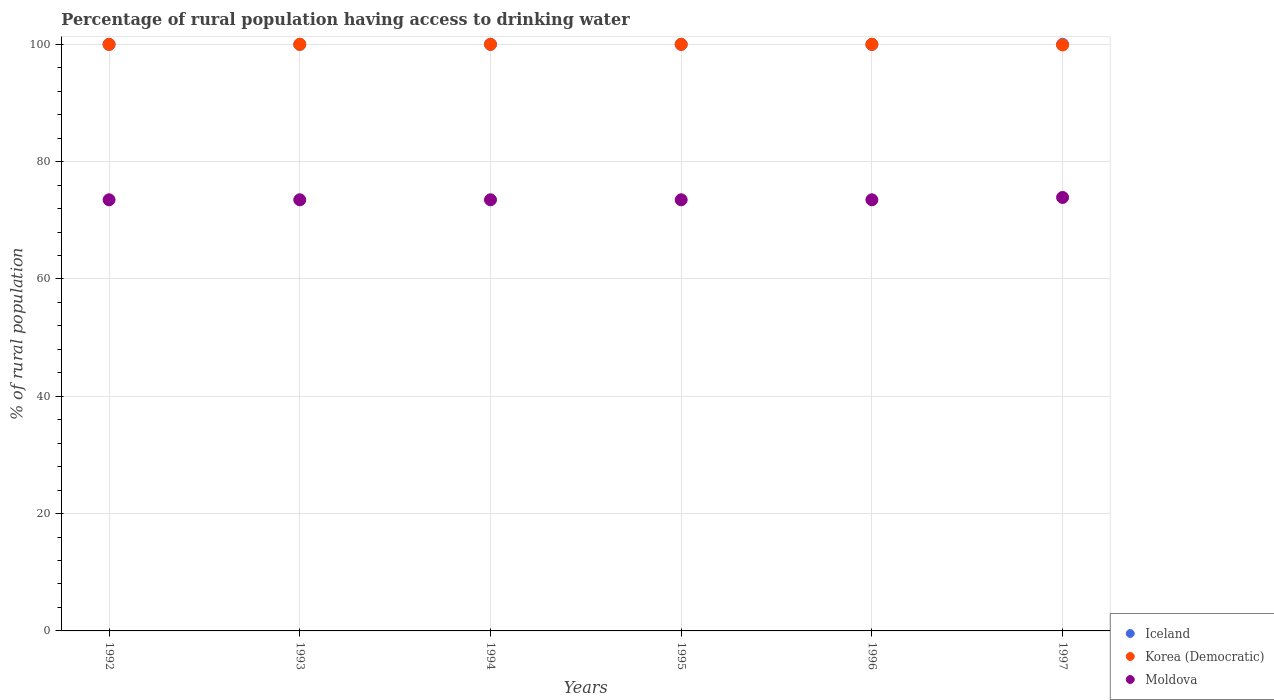Is the number of dotlines equal to the number of legend labels?
Make the answer very short. Yes. What is the percentage of rural population having access to drinking water in Moldova in 1995?
Offer a very short reply. 73.5. Across all years, what is the minimum percentage of rural population having access to drinking water in Korea (Democratic)?
Give a very brief answer. 99.9. What is the total percentage of rural population having access to drinking water in Iceland in the graph?
Your response must be concise. 600. What is the difference between the percentage of rural population having access to drinking water in Korea (Democratic) in 1992 and that in 1994?
Keep it short and to the point. 0. What is the difference between the percentage of rural population having access to drinking water in Moldova in 1992 and the percentage of rural population having access to drinking water in Iceland in 1997?
Provide a succinct answer. -26.5. What is the average percentage of rural population having access to drinking water in Moldova per year?
Give a very brief answer. 73.57. In the year 1992, what is the difference between the percentage of rural population having access to drinking water in Moldova and percentage of rural population having access to drinking water in Korea (Democratic)?
Your answer should be very brief. -26.5. What is the ratio of the percentage of rural population having access to drinking water in Moldova in 1992 to that in 1995?
Give a very brief answer. 1. Is the percentage of rural population having access to drinking water in Korea (Democratic) in 1995 less than that in 1997?
Give a very brief answer. No. Is the difference between the percentage of rural population having access to drinking water in Moldova in 1993 and 1995 greater than the difference between the percentage of rural population having access to drinking water in Korea (Democratic) in 1993 and 1995?
Provide a succinct answer. No. What is the difference between the highest and the second highest percentage of rural population having access to drinking water in Iceland?
Offer a terse response. 0. What is the difference between the highest and the lowest percentage of rural population having access to drinking water in Korea (Democratic)?
Make the answer very short. 0.1. In how many years, is the percentage of rural population having access to drinking water in Iceland greater than the average percentage of rural population having access to drinking water in Iceland taken over all years?
Your answer should be compact. 0. Is the sum of the percentage of rural population having access to drinking water in Moldova in 1992 and 1997 greater than the maximum percentage of rural population having access to drinking water in Iceland across all years?
Your answer should be compact. Yes. How many dotlines are there?
Offer a very short reply. 3. How many years are there in the graph?
Offer a terse response. 6. What is the difference between two consecutive major ticks on the Y-axis?
Your response must be concise. 20. Does the graph contain grids?
Ensure brevity in your answer.  Yes. Where does the legend appear in the graph?
Your answer should be very brief. Bottom right. How many legend labels are there?
Provide a succinct answer. 3. How are the legend labels stacked?
Offer a terse response. Vertical. What is the title of the graph?
Your answer should be very brief. Percentage of rural population having access to drinking water. Does "Macedonia" appear as one of the legend labels in the graph?
Provide a succinct answer. No. What is the label or title of the X-axis?
Your answer should be compact. Years. What is the label or title of the Y-axis?
Your response must be concise. % of rural population. What is the % of rural population of Korea (Democratic) in 1992?
Ensure brevity in your answer.  100. What is the % of rural population in Moldova in 1992?
Ensure brevity in your answer.  73.5. What is the % of rural population of Moldova in 1993?
Provide a short and direct response. 73.5. What is the % of rural population of Iceland in 1994?
Offer a terse response. 100. What is the % of rural population in Korea (Democratic) in 1994?
Give a very brief answer. 100. What is the % of rural population in Moldova in 1994?
Make the answer very short. 73.5. What is the % of rural population in Iceland in 1995?
Your answer should be very brief. 100. What is the % of rural population of Moldova in 1995?
Offer a very short reply. 73.5. What is the % of rural population in Iceland in 1996?
Ensure brevity in your answer.  100. What is the % of rural population of Moldova in 1996?
Your answer should be very brief. 73.5. What is the % of rural population in Iceland in 1997?
Offer a terse response. 100. What is the % of rural population in Korea (Democratic) in 1997?
Ensure brevity in your answer.  99.9. What is the % of rural population of Moldova in 1997?
Give a very brief answer. 73.9. Across all years, what is the maximum % of rural population in Iceland?
Offer a terse response. 100. Across all years, what is the maximum % of rural population in Korea (Democratic)?
Your answer should be very brief. 100. Across all years, what is the maximum % of rural population in Moldova?
Give a very brief answer. 73.9. Across all years, what is the minimum % of rural population of Iceland?
Offer a terse response. 100. Across all years, what is the minimum % of rural population of Korea (Democratic)?
Offer a very short reply. 99.9. Across all years, what is the minimum % of rural population in Moldova?
Your response must be concise. 73.5. What is the total % of rural population of Iceland in the graph?
Provide a succinct answer. 600. What is the total % of rural population in Korea (Democratic) in the graph?
Your answer should be compact. 599.9. What is the total % of rural population of Moldova in the graph?
Provide a succinct answer. 441.4. What is the difference between the % of rural population of Iceland in 1992 and that in 1993?
Your answer should be compact. 0. What is the difference between the % of rural population of Korea (Democratic) in 1992 and that in 1993?
Your response must be concise. 0. What is the difference between the % of rural population of Moldova in 1992 and that in 1993?
Make the answer very short. 0. What is the difference between the % of rural population of Iceland in 1992 and that in 1994?
Your answer should be compact. 0. What is the difference between the % of rural population of Korea (Democratic) in 1992 and that in 1994?
Ensure brevity in your answer.  0. What is the difference between the % of rural population in Moldova in 1992 and that in 1994?
Keep it short and to the point. 0. What is the difference between the % of rural population in Korea (Democratic) in 1992 and that in 1995?
Make the answer very short. 0. What is the difference between the % of rural population of Moldova in 1992 and that in 1995?
Your response must be concise. 0. What is the difference between the % of rural population of Iceland in 1992 and that in 1996?
Your response must be concise. 0. What is the difference between the % of rural population of Moldova in 1992 and that in 1996?
Offer a very short reply. 0. What is the difference between the % of rural population of Iceland in 1992 and that in 1997?
Give a very brief answer. 0. What is the difference between the % of rural population in Korea (Democratic) in 1992 and that in 1997?
Provide a short and direct response. 0.1. What is the difference between the % of rural population in Moldova in 1992 and that in 1997?
Your answer should be very brief. -0.4. What is the difference between the % of rural population of Iceland in 1993 and that in 1994?
Make the answer very short. 0. What is the difference between the % of rural population of Korea (Democratic) in 1993 and that in 1994?
Your answer should be compact. 0. What is the difference between the % of rural population in Moldova in 1993 and that in 1995?
Provide a succinct answer. 0. What is the difference between the % of rural population in Iceland in 1993 and that in 1996?
Give a very brief answer. 0. What is the difference between the % of rural population of Korea (Democratic) in 1993 and that in 1996?
Make the answer very short. 0. What is the difference between the % of rural population of Moldova in 1993 and that in 1996?
Give a very brief answer. 0. What is the difference between the % of rural population in Korea (Democratic) in 1993 and that in 1997?
Your answer should be compact. 0.1. What is the difference between the % of rural population in Moldova in 1993 and that in 1997?
Make the answer very short. -0.4. What is the difference between the % of rural population of Moldova in 1995 and that in 1996?
Make the answer very short. 0. What is the difference between the % of rural population of Iceland in 1996 and that in 1997?
Your answer should be very brief. 0. What is the difference between the % of rural population of Korea (Democratic) in 1996 and that in 1997?
Offer a very short reply. 0.1. What is the difference between the % of rural population of Iceland in 1992 and the % of rural population of Korea (Democratic) in 1993?
Your answer should be very brief. 0. What is the difference between the % of rural population of Korea (Democratic) in 1992 and the % of rural population of Moldova in 1993?
Offer a terse response. 26.5. What is the difference between the % of rural population in Iceland in 1992 and the % of rural population in Korea (Democratic) in 1994?
Your response must be concise. 0. What is the difference between the % of rural population of Korea (Democratic) in 1992 and the % of rural population of Moldova in 1994?
Offer a very short reply. 26.5. What is the difference between the % of rural population in Iceland in 1992 and the % of rural population in Moldova in 1995?
Offer a very short reply. 26.5. What is the difference between the % of rural population in Korea (Democratic) in 1992 and the % of rural population in Moldova in 1995?
Make the answer very short. 26.5. What is the difference between the % of rural population in Iceland in 1992 and the % of rural population in Korea (Democratic) in 1996?
Your response must be concise. 0. What is the difference between the % of rural population in Iceland in 1992 and the % of rural population in Moldova in 1996?
Ensure brevity in your answer.  26.5. What is the difference between the % of rural population in Korea (Democratic) in 1992 and the % of rural population in Moldova in 1996?
Ensure brevity in your answer.  26.5. What is the difference between the % of rural population in Iceland in 1992 and the % of rural population in Moldova in 1997?
Keep it short and to the point. 26.1. What is the difference between the % of rural population of Korea (Democratic) in 1992 and the % of rural population of Moldova in 1997?
Offer a terse response. 26.1. What is the difference between the % of rural population in Iceland in 1993 and the % of rural population in Korea (Democratic) in 1994?
Your answer should be very brief. 0. What is the difference between the % of rural population in Korea (Democratic) in 1993 and the % of rural population in Moldova in 1994?
Give a very brief answer. 26.5. What is the difference between the % of rural population of Iceland in 1993 and the % of rural population of Moldova in 1995?
Provide a succinct answer. 26.5. What is the difference between the % of rural population of Korea (Democratic) in 1993 and the % of rural population of Moldova in 1995?
Your answer should be very brief. 26.5. What is the difference between the % of rural population in Iceland in 1993 and the % of rural population in Korea (Democratic) in 1996?
Your answer should be compact. 0. What is the difference between the % of rural population of Iceland in 1993 and the % of rural population of Moldova in 1996?
Make the answer very short. 26.5. What is the difference between the % of rural population of Iceland in 1993 and the % of rural population of Korea (Democratic) in 1997?
Make the answer very short. 0.1. What is the difference between the % of rural population of Iceland in 1993 and the % of rural population of Moldova in 1997?
Your answer should be compact. 26.1. What is the difference between the % of rural population in Korea (Democratic) in 1993 and the % of rural population in Moldova in 1997?
Your answer should be very brief. 26.1. What is the difference between the % of rural population of Iceland in 1994 and the % of rural population of Korea (Democratic) in 1995?
Your response must be concise. 0. What is the difference between the % of rural population in Iceland in 1994 and the % of rural population in Moldova in 1995?
Your answer should be compact. 26.5. What is the difference between the % of rural population in Korea (Democratic) in 1994 and the % of rural population in Moldova in 1995?
Your answer should be very brief. 26.5. What is the difference between the % of rural population of Iceland in 1994 and the % of rural population of Moldova in 1996?
Make the answer very short. 26.5. What is the difference between the % of rural population of Iceland in 1994 and the % of rural population of Moldova in 1997?
Offer a very short reply. 26.1. What is the difference between the % of rural population of Korea (Democratic) in 1994 and the % of rural population of Moldova in 1997?
Offer a terse response. 26.1. What is the difference between the % of rural population of Iceland in 1995 and the % of rural population of Moldova in 1996?
Make the answer very short. 26.5. What is the difference between the % of rural population of Iceland in 1995 and the % of rural population of Korea (Democratic) in 1997?
Give a very brief answer. 0.1. What is the difference between the % of rural population in Iceland in 1995 and the % of rural population in Moldova in 1997?
Ensure brevity in your answer.  26.1. What is the difference between the % of rural population of Korea (Democratic) in 1995 and the % of rural population of Moldova in 1997?
Your response must be concise. 26.1. What is the difference between the % of rural population in Iceland in 1996 and the % of rural population in Moldova in 1997?
Your answer should be compact. 26.1. What is the difference between the % of rural population in Korea (Democratic) in 1996 and the % of rural population in Moldova in 1997?
Offer a very short reply. 26.1. What is the average % of rural population in Iceland per year?
Make the answer very short. 100. What is the average % of rural population of Korea (Democratic) per year?
Give a very brief answer. 99.98. What is the average % of rural population of Moldova per year?
Provide a short and direct response. 73.57. In the year 1993, what is the difference between the % of rural population of Iceland and % of rural population of Korea (Democratic)?
Give a very brief answer. 0. In the year 1993, what is the difference between the % of rural population of Iceland and % of rural population of Moldova?
Make the answer very short. 26.5. In the year 1994, what is the difference between the % of rural population in Iceland and % of rural population in Moldova?
Offer a very short reply. 26.5. In the year 1994, what is the difference between the % of rural population in Korea (Democratic) and % of rural population in Moldova?
Keep it short and to the point. 26.5. In the year 1995, what is the difference between the % of rural population of Iceland and % of rural population of Korea (Democratic)?
Your response must be concise. 0. In the year 1995, what is the difference between the % of rural population in Iceland and % of rural population in Moldova?
Ensure brevity in your answer.  26.5. In the year 1995, what is the difference between the % of rural population in Korea (Democratic) and % of rural population in Moldova?
Make the answer very short. 26.5. In the year 1996, what is the difference between the % of rural population in Iceland and % of rural population in Korea (Democratic)?
Offer a very short reply. 0. In the year 1996, what is the difference between the % of rural population in Korea (Democratic) and % of rural population in Moldova?
Provide a succinct answer. 26.5. In the year 1997, what is the difference between the % of rural population of Iceland and % of rural population of Moldova?
Keep it short and to the point. 26.1. In the year 1997, what is the difference between the % of rural population in Korea (Democratic) and % of rural population in Moldova?
Provide a succinct answer. 26. What is the ratio of the % of rural population of Korea (Democratic) in 1992 to that in 1993?
Ensure brevity in your answer.  1. What is the ratio of the % of rural population in Moldova in 1992 to that in 1994?
Offer a terse response. 1. What is the ratio of the % of rural population in Korea (Democratic) in 1992 to that in 1995?
Your answer should be very brief. 1. What is the ratio of the % of rural population in Moldova in 1992 to that in 1995?
Offer a very short reply. 1. What is the ratio of the % of rural population in Iceland in 1992 to that in 1996?
Provide a short and direct response. 1. What is the ratio of the % of rural population in Korea (Democratic) in 1992 to that in 1996?
Offer a terse response. 1. What is the ratio of the % of rural population in Korea (Democratic) in 1992 to that in 1997?
Offer a terse response. 1. What is the ratio of the % of rural population in Moldova in 1993 to that in 1994?
Provide a succinct answer. 1. What is the ratio of the % of rural population in Moldova in 1993 to that in 1995?
Your answer should be compact. 1. What is the ratio of the % of rural population in Iceland in 1993 to that in 1996?
Give a very brief answer. 1. What is the ratio of the % of rural population in Iceland in 1993 to that in 1997?
Offer a terse response. 1. What is the ratio of the % of rural population of Moldova in 1993 to that in 1997?
Offer a terse response. 0.99. What is the ratio of the % of rural population in Korea (Democratic) in 1994 to that in 1995?
Offer a terse response. 1. What is the ratio of the % of rural population of Moldova in 1994 to that in 1996?
Ensure brevity in your answer.  1. What is the ratio of the % of rural population of Korea (Democratic) in 1994 to that in 1997?
Keep it short and to the point. 1. What is the ratio of the % of rural population of Moldova in 1994 to that in 1997?
Your response must be concise. 0.99. What is the ratio of the % of rural population in Iceland in 1995 to that in 1997?
Provide a succinct answer. 1. What is the ratio of the % of rural population in Korea (Democratic) in 1995 to that in 1997?
Provide a short and direct response. 1. What is the ratio of the % of rural population of Iceland in 1996 to that in 1997?
Provide a succinct answer. 1. What is the ratio of the % of rural population in Moldova in 1996 to that in 1997?
Offer a very short reply. 0.99. What is the difference between the highest and the lowest % of rural population of Iceland?
Offer a very short reply. 0. 